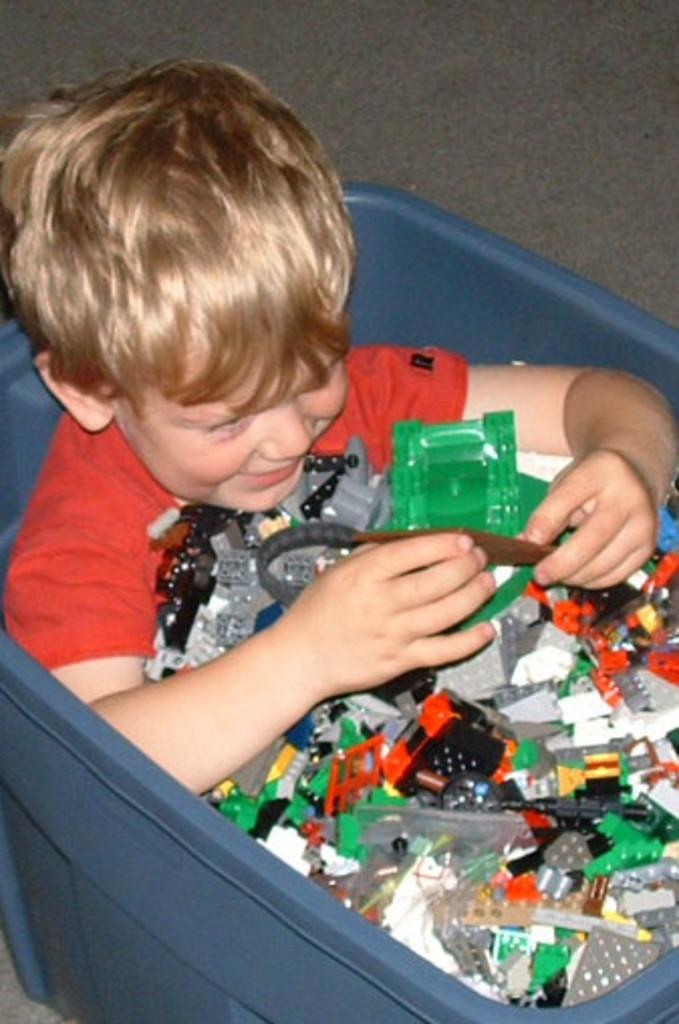What is the person in the image sitting inside? The person is sitting inside a blue box in the image. What color is the person's top? The person is wearing a red top. What can be seen inside the box besides the person? There are multicolor objects visible inside the box. What type of land can be seen in the image? There is no land visible in the image, as the person is sitting inside a blue box. 